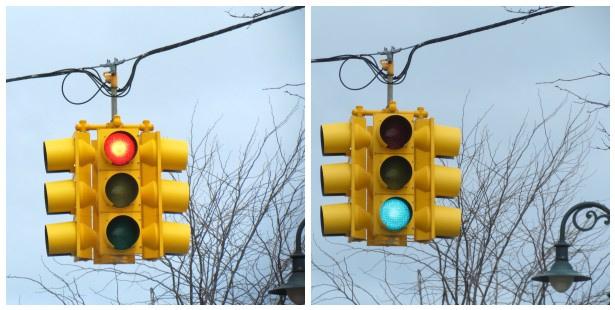Which color means "go"?
Short answer required. Green. Do these traffic lights mean the same thing?
Be succinct. No. Are both of these pictures of the same traffic light?
Concise answer only. Yes. 